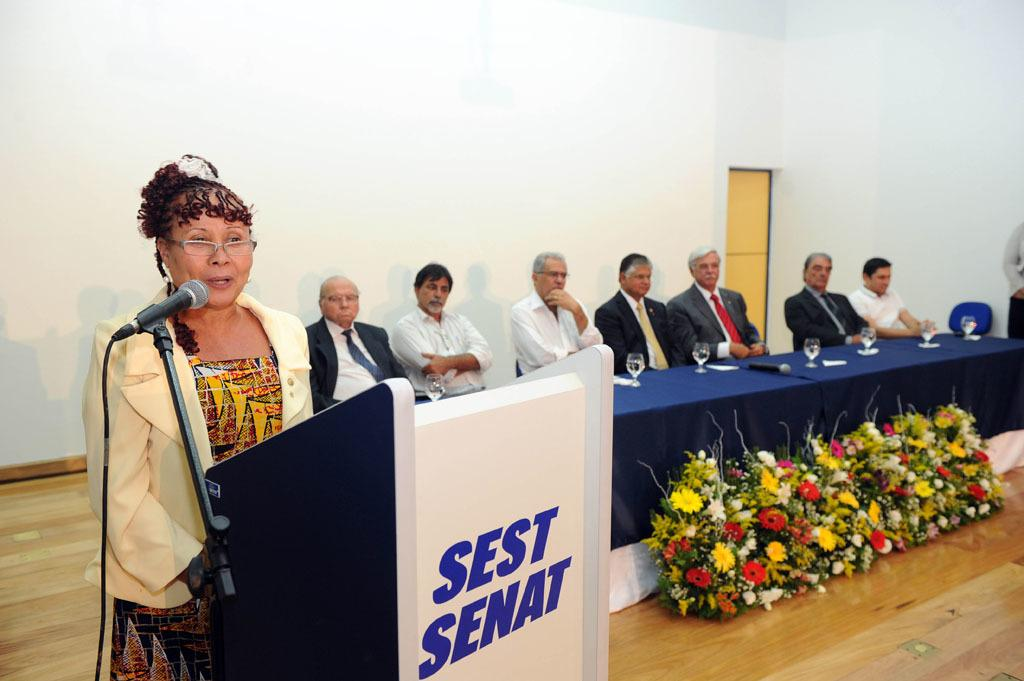<image>
Create a compact narrative representing the image presented. A speaker at a podium labeled Sest Senat with 7 men seated at a long table behind and to the side. 